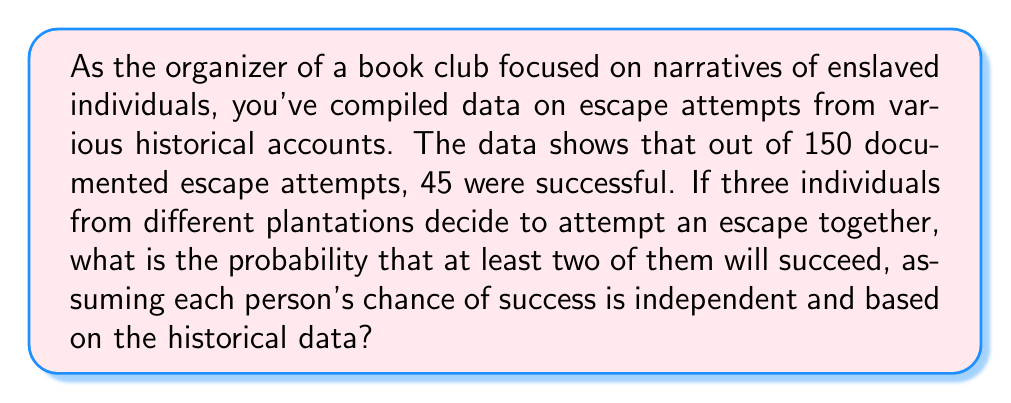Help me with this question. Let's approach this step-by-step:

1) First, we need to calculate the probability of a single escape attempt being successful:

   $P(\text{success}) = \frac{45}{150} = 0.3$ or 30%

2) Now, we need to find the probability of at least two out of three people succeeding. This is equivalent to the probability of either two succeeding and one failing, or all three succeeding.

3) Let's use the binomial probability formula:

   $P(X = k) = \binom{n}{k} p^k (1-p)^{n-k}$

   Where:
   $n$ = number of trials (3 in this case)
   $k$ = number of successes
   $p$ = probability of success on a single trial (0.3)

4) Probability of exactly two succeeding:

   $P(X = 2) = \binom{3}{2} (0.3)^2 (0.7)^1$
   
   $= 3 \times 0.09 \times 0.7 = 0.189$

5) Probability of all three succeeding:

   $P(X = 3) = \binom{3}{3} (0.3)^3 (0.7)^0$
   
   $= 1 \times 0.027 \times 1 = 0.027$

6) The probability of at least two succeeding is the sum of these probabilities:

   $P(\text{at least two succeed}) = P(X = 2) + P(X = 3)$
   
   $= 0.189 + 0.027 = 0.216$
Answer: The probability that at least two of the three individuals will succeed in their escape attempt is 0.216 or 21.6%. 